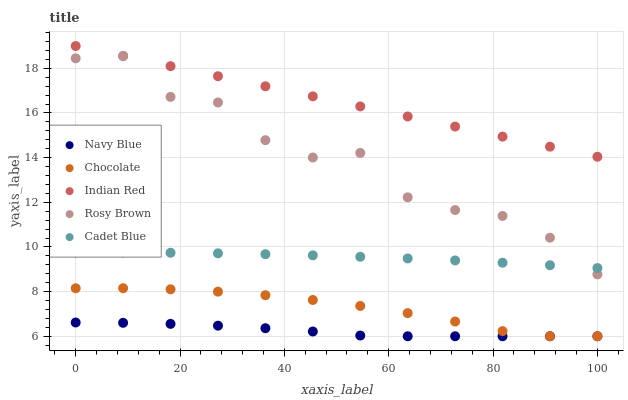Does Navy Blue have the minimum area under the curve?
Answer yes or no. Yes. Does Indian Red have the maximum area under the curve?
Answer yes or no. Yes. Does Rosy Brown have the minimum area under the curve?
Answer yes or no. No. Does Rosy Brown have the maximum area under the curve?
Answer yes or no. No. Is Indian Red the smoothest?
Answer yes or no. Yes. Is Rosy Brown the roughest?
Answer yes or no. Yes. Is Navy Blue the smoothest?
Answer yes or no. No. Is Navy Blue the roughest?
Answer yes or no. No. Does Navy Blue have the lowest value?
Answer yes or no. Yes. Does Rosy Brown have the lowest value?
Answer yes or no. No. Does Indian Red have the highest value?
Answer yes or no. Yes. Does Rosy Brown have the highest value?
Answer yes or no. No. Is Chocolate less than Cadet Blue?
Answer yes or no. Yes. Is Rosy Brown greater than Chocolate?
Answer yes or no. Yes. Does Rosy Brown intersect Indian Red?
Answer yes or no. Yes. Is Rosy Brown less than Indian Red?
Answer yes or no. No. Is Rosy Brown greater than Indian Red?
Answer yes or no. No. Does Chocolate intersect Cadet Blue?
Answer yes or no. No. 